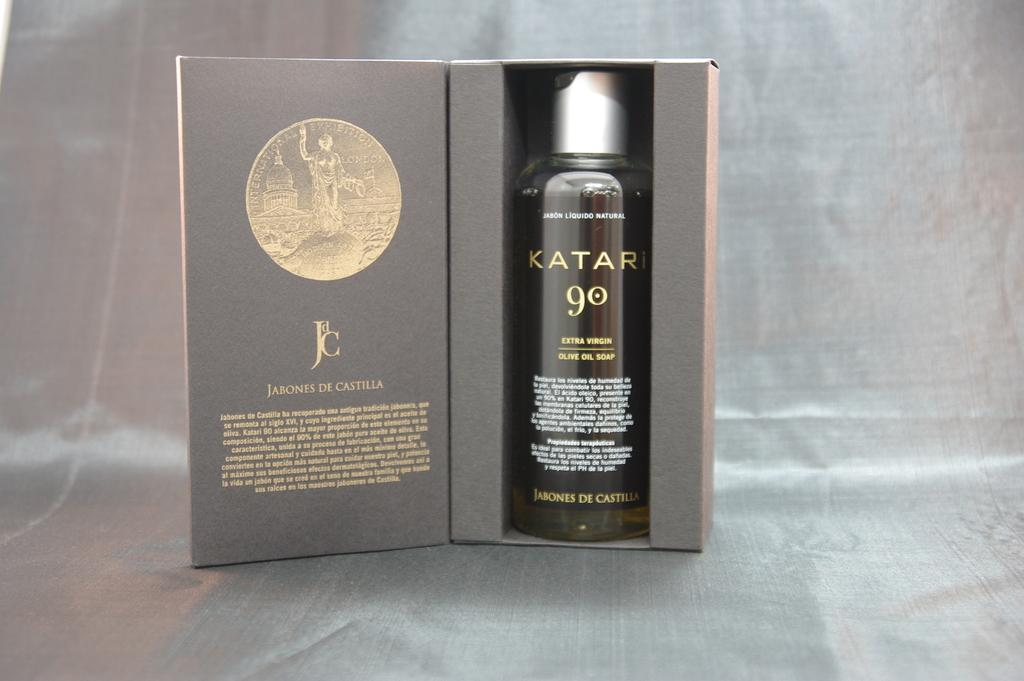<image>
Create a compact narrative representing the image presented. Open box showing a bottle of Katai 90. 